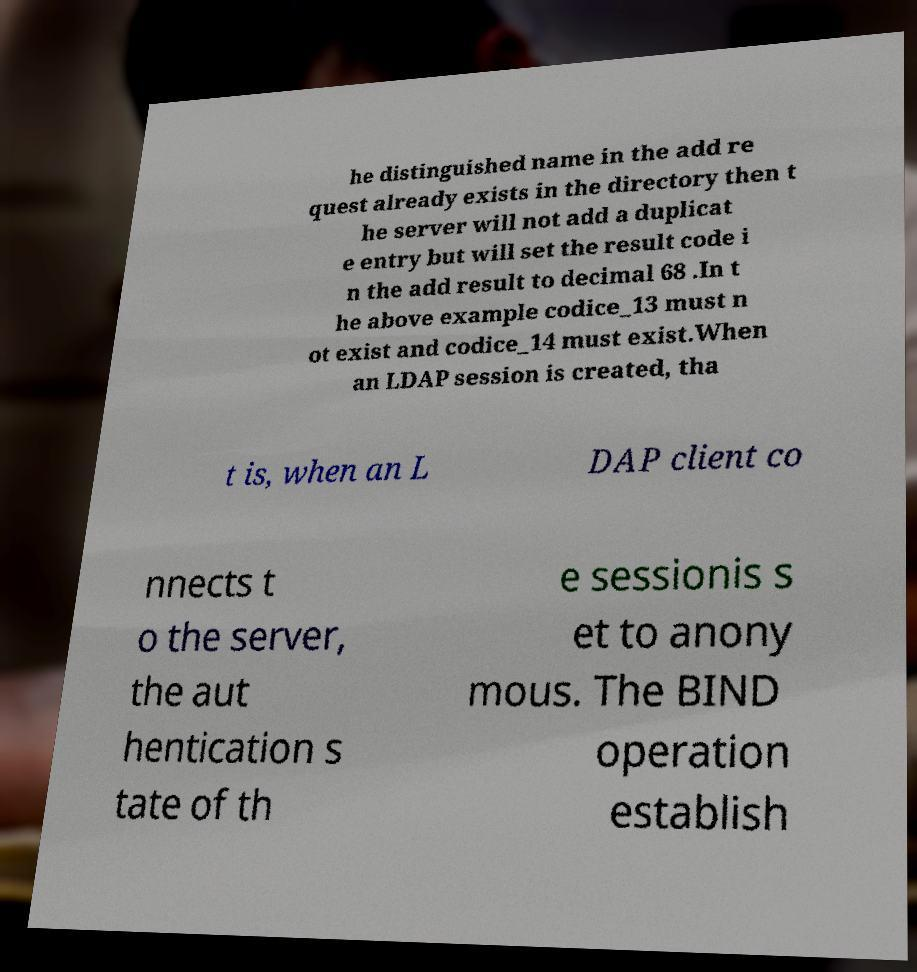Can you accurately transcribe the text from the provided image for me? he distinguished name in the add re quest already exists in the directory then t he server will not add a duplicat e entry but will set the result code i n the add result to decimal 68 .In t he above example codice_13 must n ot exist and codice_14 must exist.When an LDAP session is created, tha t is, when an L DAP client co nnects t o the server, the aut hentication s tate of th e sessionis s et to anony mous. The BIND operation establish 